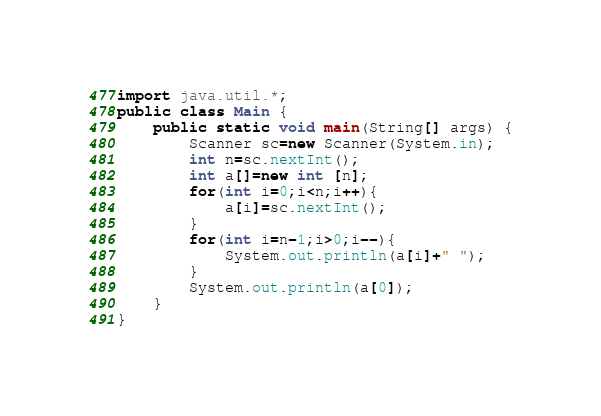Convert code to text. <code><loc_0><loc_0><loc_500><loc_500><_Java_>import java.util.*;
public class Main {
	public static void main(String[] args) {
		Scanner sc=new Scanner(System.in);
		int n=sc.nextInt();
		int a[]=new int [n];
		for(int i=0;i<n;i++){
			a[i]=sc.nextInt();
		}
		for(int i=n-1;i>0;i--){
			System.out.println(a[i]+" ");
		}
		System.out.println(a[0]);
	}
}</code> 